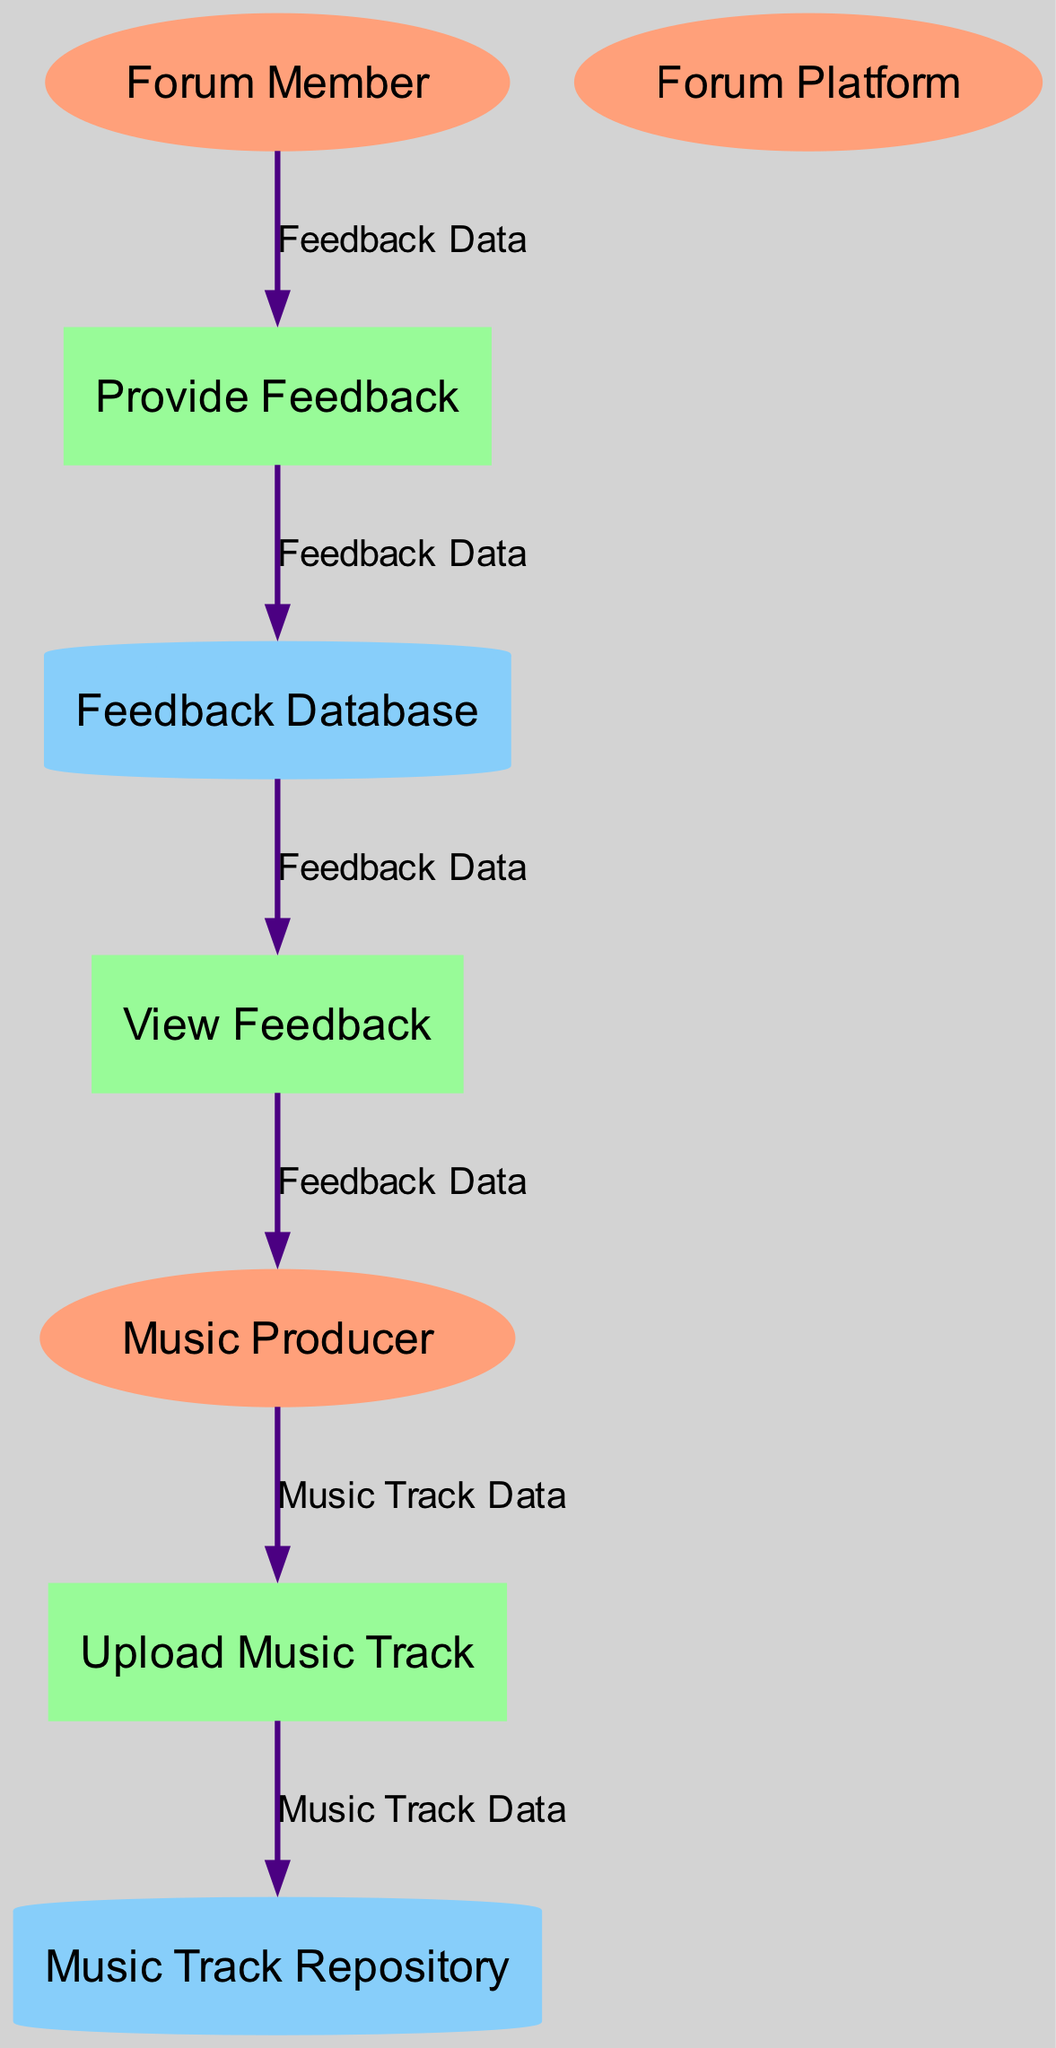What is the role of the Music Producer in the diagram? The Music Producer is responsible for uploading music tracks to the Forum Platform, initiating the workflow for collecting feedback.
Answer: Music Producer How many data stores are represented in the diagram? There are two data stores: Music Track Repository and Feedback Database, which are used to store uploaded tracks and feedback, respectively.
Answer: 2 What does the Provide Feedback process receive as input? The Provide Feedback process receives Feedback Data from Forum Members, who listen to the music tracks and provide their comments.
Answer: Feedback Data Which entity generates the Feedback Data? The Forum Member generates Feedback Data by providing constructive criticism on the music tracks uploaded by the Music Producer.
Answer: Forum Member What is the first process in the data flow? The first process in the data flow is Upload Music Track, which is initiated by the Music Producer when a track is uploaded to the Forum Platform.
Answer: Upload Music Track How does the Feedback Database relate to the View Feedback process? The Feedback Database supplies Feedback Data to the View Feedback process, enabling the Music Producer to see the feedback received on their tracks.
Answer: It supplies Feedback Data What is the main output of the View Feedback process? The main output of the View Feedback process is Feedback Data, which the Music Producer views after gathering responses from Forum Members.
Answer: Feedback Data What do Forum Members do after listening to a track? After listening to a track, Forum Members provide feedback through the Provide Feedback process, contributing to the feedback collection mechanism.
Answer: Provide feedback How many processes are depicted in the data flow? There are three processes depicted in the data flow: Upload Music Track, Provide Feedback, and View Feedback, each playing a specific role in user interaction.
Answer: 3 